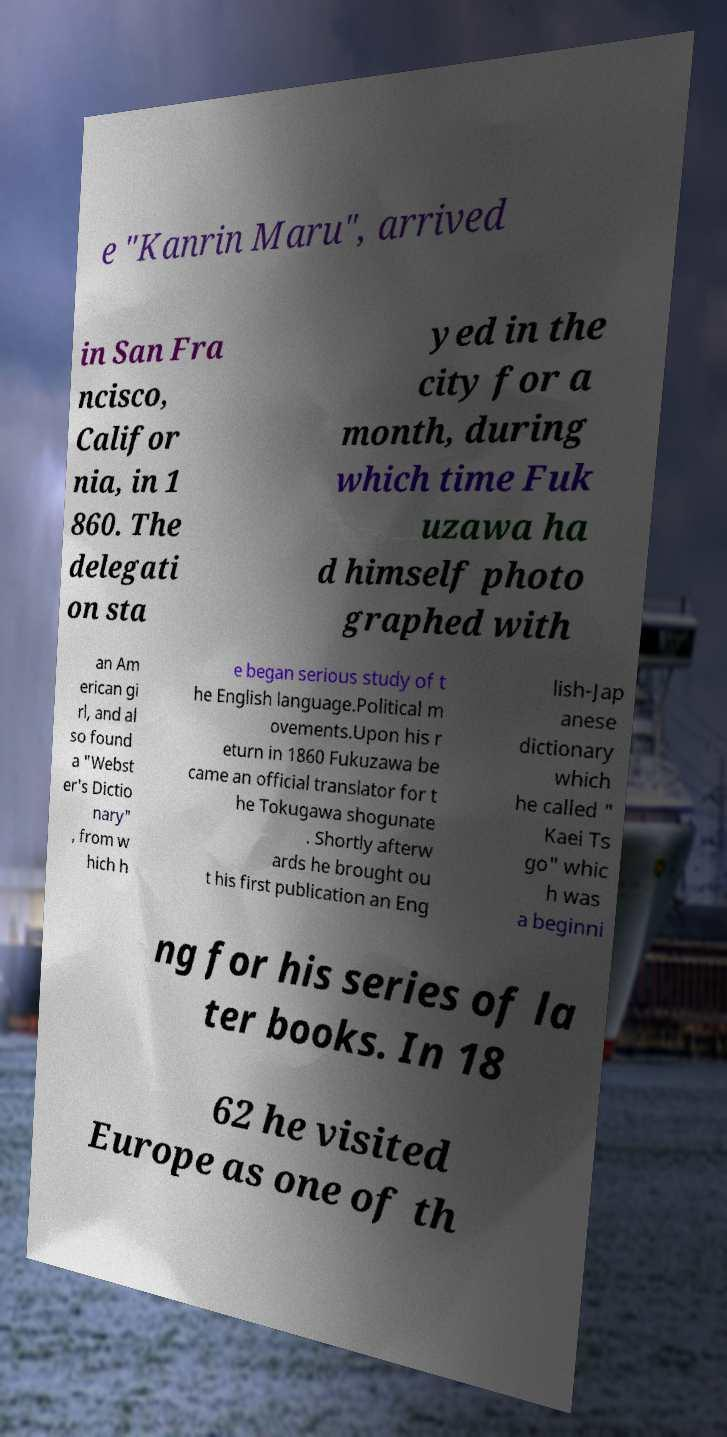Please read and relay the text visible in this image. What does it say? e "Kanrin Maru", arrived in San Fra ncisco, Califor nia, in 1 860. The delegati on sta yed in the city for a month, during which time Fuk uzawa ha d himself photo graphed with an Am erican gi rl, and al so found a "Webst er's Dictio nary" , from w hich h e began serious study of t he English language.Political m ovements.Upon his r eturn in 1860 Fukuzawa be came an official translator for t he Tokugawa shogunate . Shortly afterw ards he brought ou t his first publication an Eng lish-Jap anese dictionary which he called " Kaei Ts go" whic h was a beginni ng for his series of la ter books. In 18 62 he visited Europe as one of th 